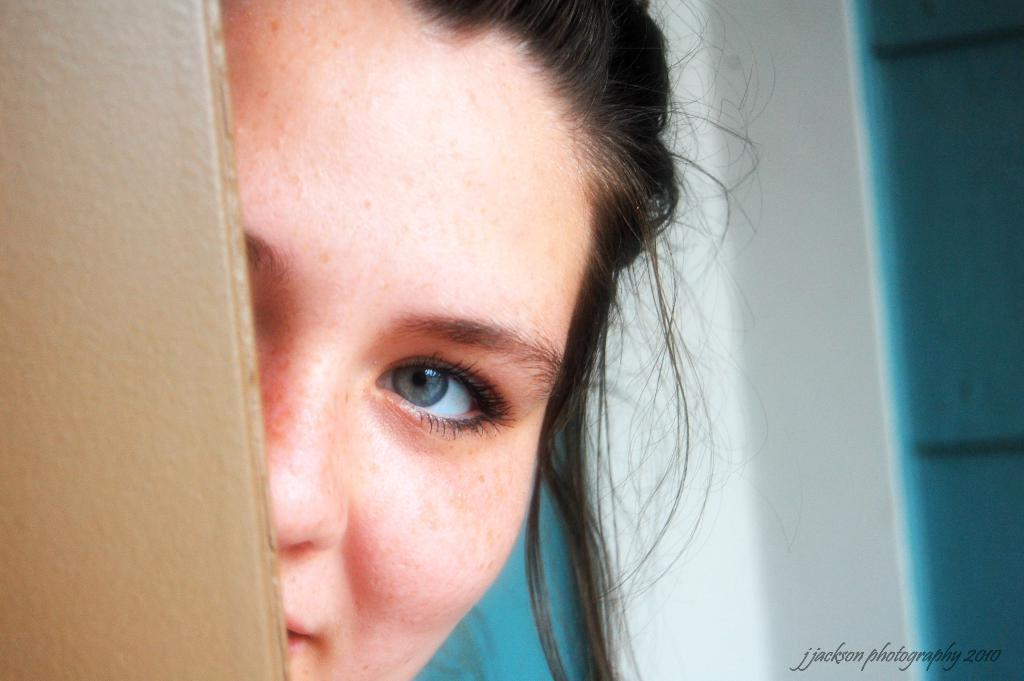What is the main subject of the image? There is a person's face in the image. What can be seen in the background of the image? There is a wall in the image. What else is visible in the image besides the person's face and the wall? There are objects in the image. Where is the text located in the image? The text is in the bottom right corner of the image. What type of chalk is being used to write the letters in the image? There is no chalk or letters being written in the image. 